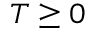Convert formula to latex. <formula><loc_0><loc_0><loc_500><loc_500>T \geq 0</formula> 